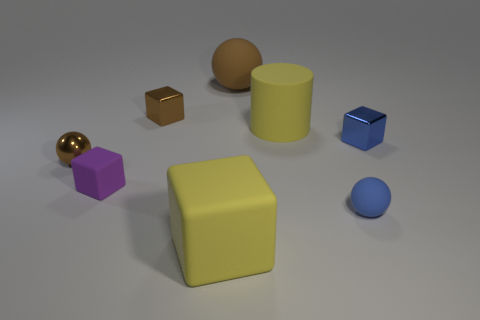Do the metal sphere and the small matte sphere have the same color?
Provide a short and direct response. No. Are there more tiny metal cylinders than shiny spheres?
Provide a succinct answer. No. What number of other things are there of the same material as the small brown cube
Keep it short and to the point. 2. How many tiny blue things are in front of the matte block that is behind the small sphere right of the tiny brown cube?
Offer a very short reply. 1. How many shiny objects are green cylinders or tiny blue spheres?
Your answer should be very brief. 0. How big is the rubber ball behind the thing on the left side of the tiny purple object?
Your answer should be compact. Large. Is the color of the rubber object that is behind the tiny brown shiny cube the same as the metallic block that is right of the yellow cylinder?
Offer a terse response. No. There is a object that is both right of the big cylinder and left of the small blue metallic cube; what is its color?
Your response must be concise. Blue. Do the small purple cube and the large yellow block have the same material?
Give a very brief answer. Yes. What number of large objects are either matte objects or green rubber balls?
Keep it short and to the point. 3. 